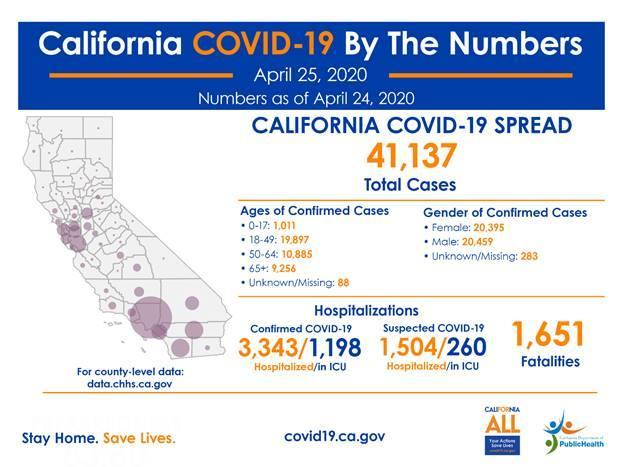what is the total number of confirmed cases whose age is in between 18-64?
Answer the question with a short phrase. 30782 what is the total number of confirmed cases of men and women combined? 40854 what is the total number of confirmed cases whose age is above 50? 20141 In which gender group most number of cases belong? male what is the total number of confirmed cases whose age is below 50? 20908 In which age group most number of cases belong? 18-49 in which age group more number of confirmed cases belong - 0-17 or 65+? 65+ what is the difference between hospitalized confirmed and suspected cases? 1839 what is the difference between confirmed and suspected cases in ICU? 938 in which age group more number of confirmed cases belong - 18-49 or 50-64? 18-49 what is the total number of confirmed cases whose age is below 65? 31793 In which age group least number of cases belong? 0-17 